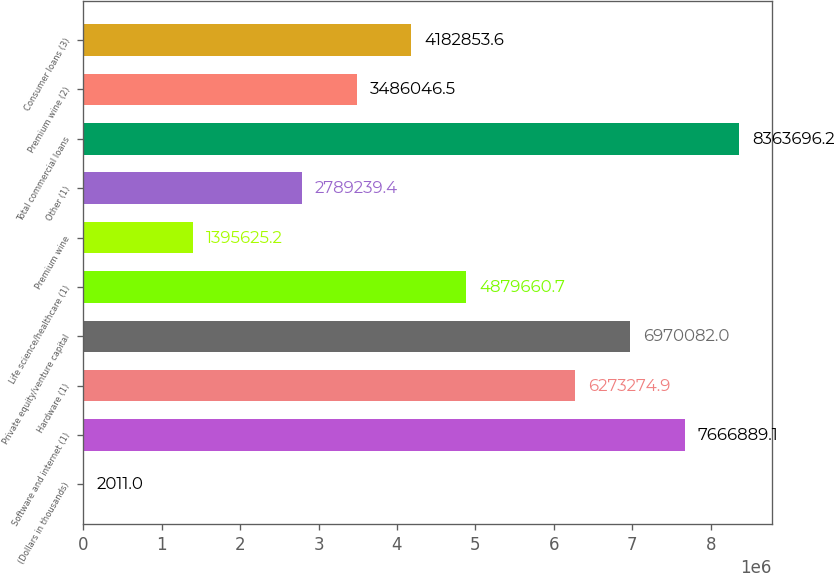<chart> <loc_0><loc_0><loc_500><loc_500><bar_chart><fcel>(Dollars in thousands)<fcel>Software and internet (1)<fcel>Hardware (1)<fcel>Private equity/venture capital<fcel>Life science/healthcare (1)<fcel>Premium wine<fcel>Other (1)<fcel>Total commercial loans<fcel>Premium wine (2)<fcel>Consumer loans (3)<nl><fcel>2011<fcel>7.66689e+06<fcel>6.27327e+06<fcel>6.97008e+06<fcel>4.87966e+06<fcel>1.39563e+06<fcel>2.78924e+06<fcel>8.3637e+06<fcel>3.48605e+06<fcel>4.18285e+06<nl></chart> 